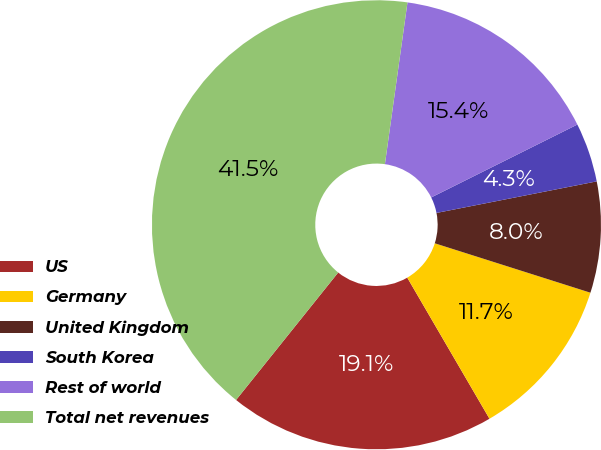<chart> <loc_0><loc_0><loc_500><loc_500><pie_chart><fcel>US<fcel>Germany<fcel>United Kingdom<fcel>South Korea<fcel>Rest of world<fcel>Total net revenues<nl><fcel>19.15%<fcel>11.71%<fcel>7.99%<fcel>4.27%<fcel>15.43%<fcel>41.46%<nl></chart> 